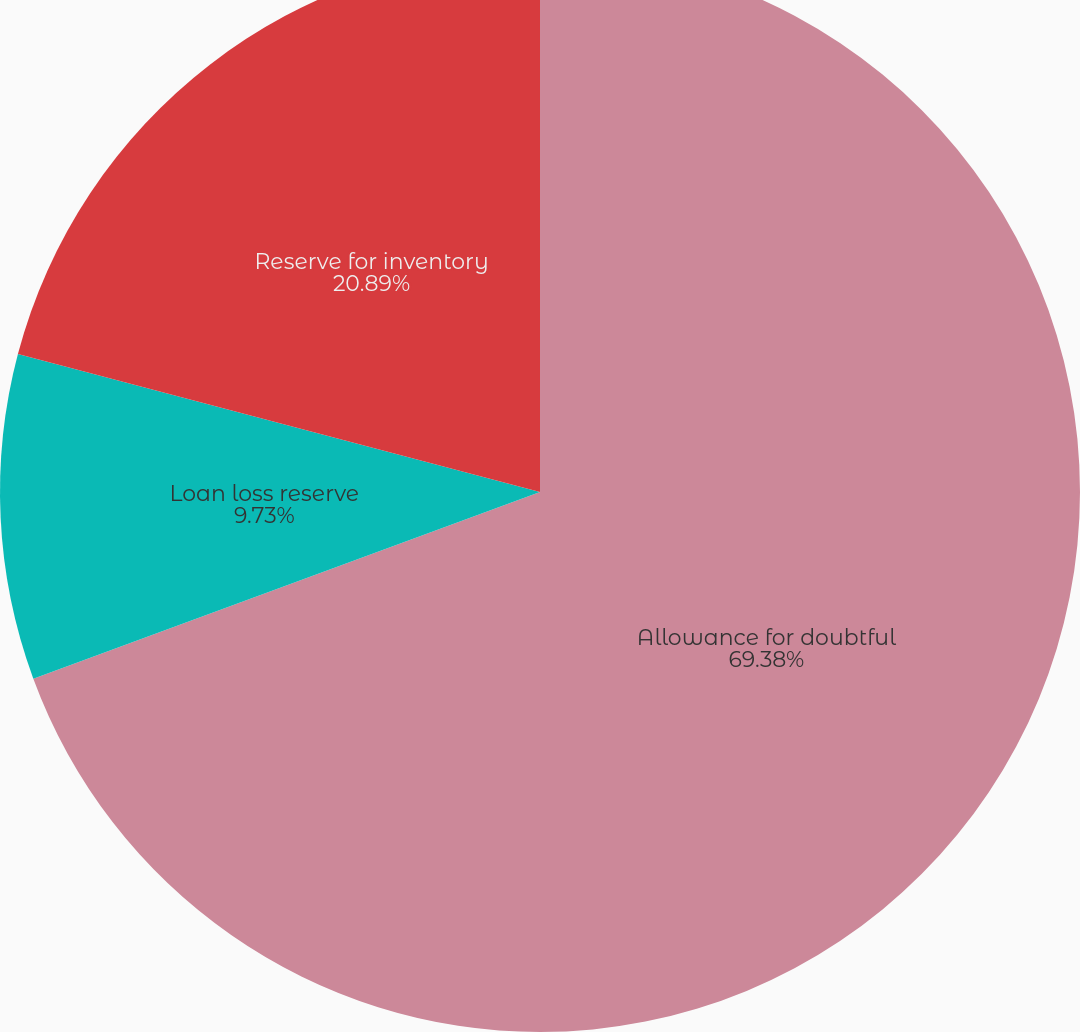<chart> <loc_0><loc_0><loc_500><loc_500><pie_chart><fcel>Allowance for doubtful<fcel>Loan loss reserve<fcel>Reserve for inventory<nl><fcel>69.38%<fcel>9.73%<fcel>20.89%<nl></chart> 